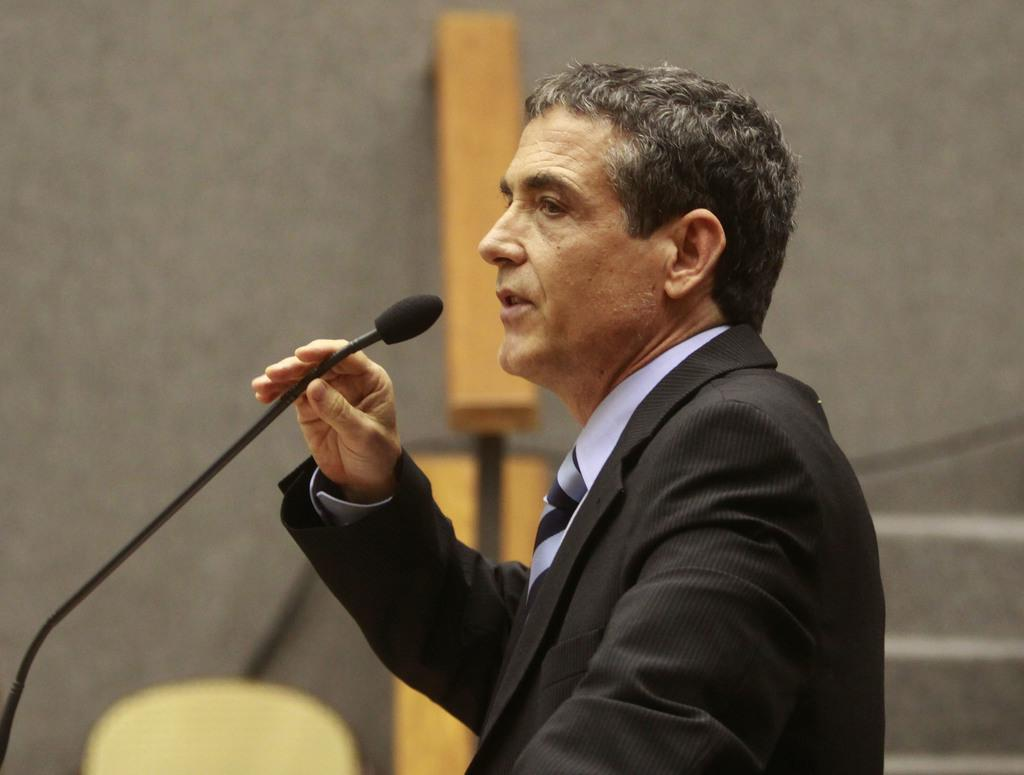Who is the main subject in the image? There is a person in the image. What is the person wearing? The person is wearing a black coat. What is the person holding in the image? The person is holding a mic. What is the person doing in the image? The person is talking. What can be seen in the background of the image? There is a wall in the background of the image. What degree does the person in the image have? There is no information about the person's degree in the image. 